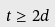<formula> <loc_0><loc_0><loc_500><loc_500>t \geq 2 d</formula> 